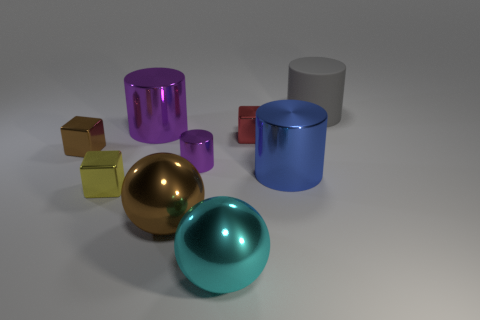Subtract all green balls. How many purple cylinders are left? 2 Subtract all big cylinders. How many cylinders are left? 1 Subtract 1 blocks. How many blocks are left? 2 Subtract all gray cylinders. How many cylinders are left? 3 Subtract all blocks. How many objects are left? 6 Add 7 large blue objects. How many large blue objects exist? 8 Subtract 1 purple cylinders. How many objects are left? 8 Subtract all green cubes. Subtract all yellow cylinders. How many cubes are left? 3 Subtract all big objects. Subtract all small brown rubber cubes. How many objects are left? 4 Add 3 yellow blocks. How many yellow blocks are left? 4 